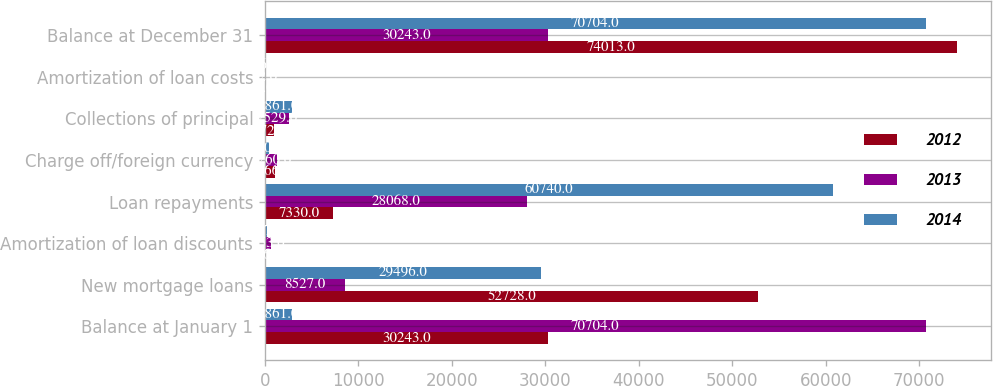<chart> <loc_0><loc_0><loc_500><loc_500><stacked_bar_chart><ecel><fcel>Balance at January 1<fcel>New mortgage loans<fcel>Amortization of loan discounts<fcel>Loan repayments<fcel>Charge off/foreign currency<fcel>Collections of principal<fcel>Amortization of loan costs<fcel>Balance at December 31<nl><fcel>2012<fcel>30243<fcel>52728<fcel>126<fcel>7330<fcel>1066<fcel>972<fcel>2<fcel>74013<nl><fcel>2013<fcel>70704<fcel>8527<fcel>653<fcel>28068<fcel>1260<fcel>2529<fcel>22<fcel>30243<nl><fcel>2014<fcel>2861<fcel>29496<fcel>247<fcel>60740<fcel>430<fcel>2861<fcel>56<fcel>70704<nl></chart> 